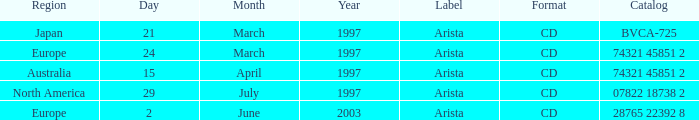What Label has the Region of Australia? Arista. 